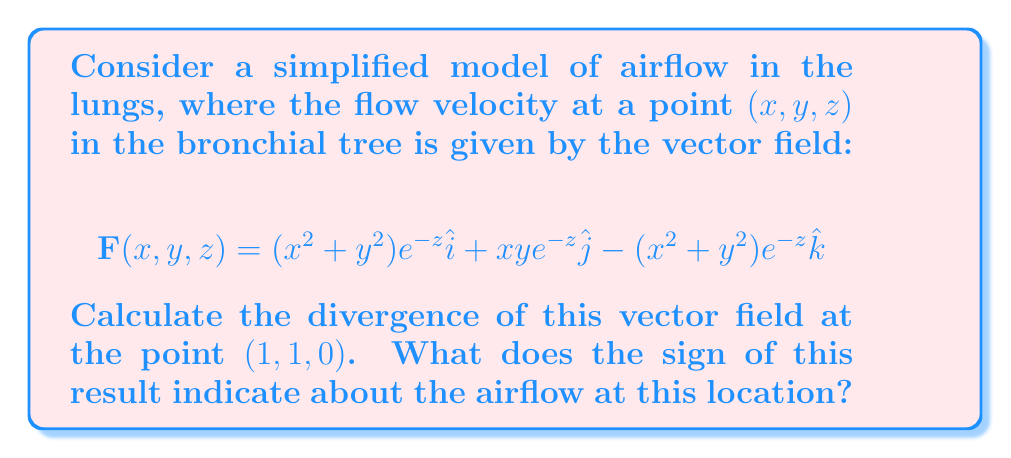Show me your answer to this math problem. To solve this problem, we'll follow these steps:

1) The divergence of a vector field $\mathbf{F}(x,y,z) = P\hat{i} + Q\hat{j} + R\hat{k}$ is given by:

   $$\nabla \cdot \mathbf{F} = \frac{\partial P}{\partial x} + \frac{\partial Q}{\partial y} + \frac{\partial R}{\partial z}$$

2) In our case:
   $P = (x^2+y^2)e^{-z}$
   $Q = xye^{-z}$
   $R = -(x^2+y^2)e^{-z}$

3) Let's calculate each partial derivative:

   $\frac{\partial P}{\partial x} = 2xe^{-z}$
   
   $\frac{\partial Q}{\partial y} = xe^{-z}$
   
   $\frac{\partial R}{\partial z} = (x^2+y^2)e^{-z}$

4) Now, we can sum these to get the divergence:

   $$\nabla \cdot \mathbf{F} = 2xe^{-z} + xe^{-z} + (x^2+y^2)e^{-z}$$

5) Simplify:

   $$\nabla \cdot \mathbf{F} = (3x + x^2 + y^2)e^{-z}$$

6) Evaluate at the point $(1,1,0)$:

   $$\nabla \cdot \mathbf{F}|_{(1,1,0)} = (3(1) + 1^2 + 1^2)e^{-0} = 5$$

7) Interpretation: The positive divergence indicates that this point is a source of airflow, meaning air is flowing out from this point in the lungs. This could represent a point where air is being expelled during exhalation.
Answer: 5; positive divergence indicates a source of airflow (point of exhalation) 